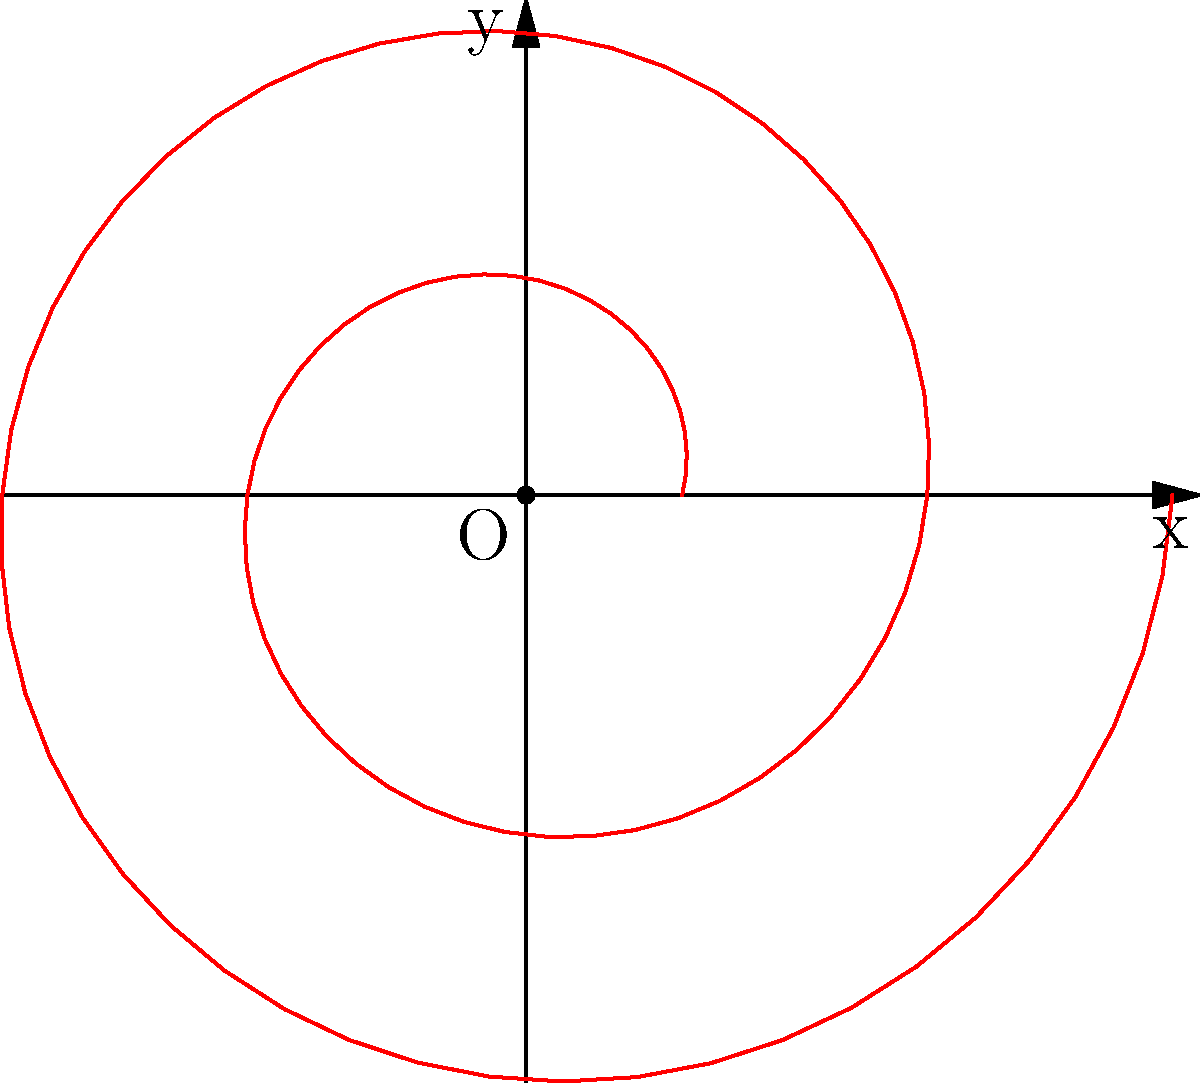You are designing a spiral-shaped light diffuser for an energy-efficient lamp. The spiral curve is defined by the polar equation $r = 2 + 0.5\theta$, where $r$ is in centimeters and $\theta$ is in radians. Calculate the total length of the spiral curve from $\theta = 0$ to $\theta = 4\pi$ radians. To find the length of the spiral curve, we need to use the arc length formula for polar curves:

1) The formula for the arc length $L$ of a polar curve from $\theta = a$ to $\theta = b$ is:

   $$L = \int_{a}^{b} \sqrt{r^2 + \left(\frac{dr}{d\theta}\right)^2} d\theta$$

2) For our spiral, $r = 2 + 0.5\theta$ and $\frac{dr}{d\theta} = 0.5$

3) Substituting these into the formula:

   $$L = \int_{0}^{4\pi} \sqrt{(2 + 0.5\theta)^2 + (0.5)^2} d\theta$$

4) Simplify inside the square root:

   $$L = \int_{0}^{4\pi} \sqrt{4 + 2\theta + 0.25\theta^2 + 0.25} d\theta$$

   $$L = \int_{0}^{4\pi} \sqrt{4.25 + 2\theta + 0.25\theta^2} d\theta$$

5) This integral cannot be solved analytically. We need to use numerical integration methods.

6) Using a numerical integration tool or computer algebra system, we get:

   $$L \approx 33.85 \text{ cm}$$

Thus, the total length of the spiral curve is approximately 33.85 cm.
Answer: 33.85 cm 